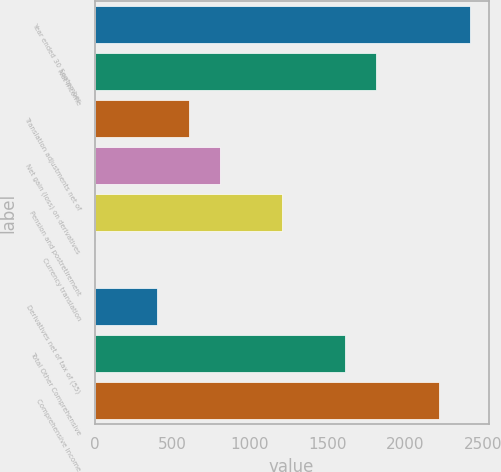Convert chart. <chart><loc_0><loc_0><loc_500><loc_500><bar_chart><fcel>Year ended 30 September<fcel>Net Income<fcel>Translation adjustments net of<fcel>Net gain (loss) on derivatives<fcel>Pension and postretirement<fcel>Currency translation<fcel>Derivatives net of tax of (55)<fcel>Total Other Comprehensive<fcel>Comprehensive Income<nl><fcel>2415.48<fcel>1811.76<fcel>604.32<fcel>805.56<fcel>1208.04<fcel>0.6<fcel>403.08<fcel>1610.52<fcel>2214.24<nl></chart> 